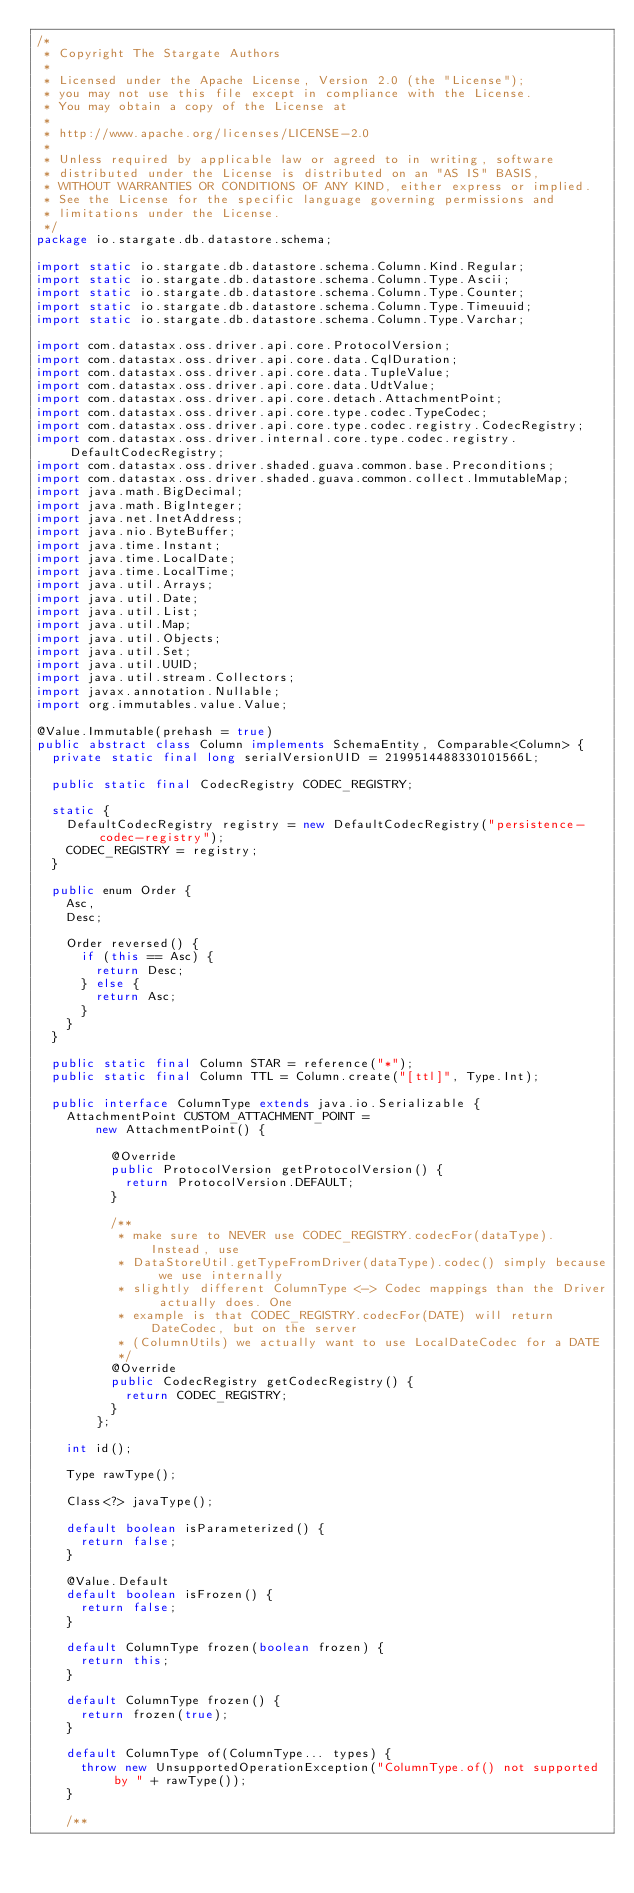<code> <loc_0><loc_0><loc_500><loc_500><_Java_>/*
 * Copyright The Stargate Authors
 *
 * Licensed under the Apache License, Version 2.0 (the "License");
 * you may not use this file except in compliance with the License.
 * You may obtain a copy of the License at
 *
 * http://www.apache.org/licenses/LICENSE-2.0
 *
 * Unless required by applicable law or agreed to in writing, software
 * distributed under the License is distributed on an "AS IS" BASIS,
 * WITHOUT WARRANTIES OR CONDITIONS OF ANY KIND, either express or implied.
 * See the License for the specific language governing permissions and
 * limitations under the License.
 */
package io.stargate.db.datastore.schema;

import static io.stargate.db.datastore.schema.Column.Kind.Regular;
import static io.stargate.db.datastore.schema.Column.Type.Ascii;
import static io.stargate.db.datastore.schema.Column.Type.Counter;
import static io.stargate.db.datastore.schema.Column.Type.Timeuuid;
import static io.stargate.db.datastore.schema.Column.Type.Varchar;

import com.datastax.oss.driver.api.core.ProtocolVersion;
import com.datastax.oss.driver.api.core.data.CqlDuration;
import com.datastax.oss.driver.api.core.data.TupleValue;
import com.datastax.oss.driver.api.core.data.UdtValue;
import com.datastax.oss.driver.api.core.detach.AttachmentPoint;
import com.datastax.oss.driver.api.core.type.codec.TypeCodec;
import com.datastax.oss.driver.api.core.type.codec.registry.CodecRegistry;
import com.datastax.oss.driver.internal.core.type.codec.registry.DefaultCodecRegistry;
import com.datastax.oss.driver.shaded.guava.common.base.Preconditions;
import com.datastax.oss.driver.shaded.guava.common.collect.ImmutableMap;
import java.math.BigDecimal;
import java.math.BigInteger;
import java.net.InetAddress;
import java.nio.ByteBuffer;
import java.time.Instant;
import java.time.LocalDate;
import java.time.LocalTime;
import java.util.Arrays;
import java.util.Date;
import java.util.List;
import java.util.Map;
import java.util.Objects;
import java.util.Set;
import java.util.UUID;
import java.util.stream.Collectors;
import javax.annotation.Nullable;
import org.immutables.value.Value;

@Value.Immutable(prehash = true)
public abstract class Column implements SchemaEntity, Comparable<Column> {
  private static final long serialVersionUID = 2199514488330101566L;

  public static final CodecRegistry CODEC_REGISTRY;

  static {
    DefaultCodecRegistry registry = new DefaultCodecRegistry("persistence-codec-registry");
    CODEC_REGISTRY = registry;
  }

  public enum Order {
    Asc,
    Desc;

    Order reversed() {
      if (this == Asc) {
        return Desc;
      } else {
        return Asc;
      }
    }
  }

  public static final Column STAR = reference("*");
  public static final Column TTL = Column.create("[ttl]", Type.Int);

  public interface ColumnType extends java.io.Serializable {
    AttachmentPoint CUSTOM_ATTACHMENT_POINT =
        new AttachmentPoint() {

          @Override
          public ProtocolVersion getProtocolVersion() {
            return ProtocolVersion.DEFAULT;
          }

          /**
           * make sure to NEVER use CODEC_REGISTRY.codecFor(dataType). Instead, use
           * DataStoreUtil.getTypeFromDriver(dataType).codec() simply because we use internally
           * slightly different ColumnType <-> Codec mappings than the Driver actually does. One
           * example is that CODEC_REGISTRY.codecFor(DATE) will return DateCodec, but on the server
           * (ColumnUtils) we actually want to use LocalDateCodec for a DATE
           */
          @Override
          public CodecRegistry getCodecRegistry() {
            return CODEC_REGISTRY;
          }
        };

    int id();

    Type rawType();

    Class<?> javaType();

    default boolean isParameterized() {
      return false;
    }

    @Value.Default
    default boolean isFrozen() {
      return false;
    }

    default ColumnType frozen(boolean frozen) {
      return this;
    }

    default ColumnType frozen() {
      return frozen(true);
    }

    default ColumnType of(ColumnType... types) {
      throw new UnsupportedOperationException("ColumnType.of() not supported by " + rawType());
    }

    /**</code> 